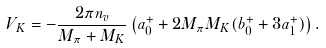<formula> <loc_0><loc_0><loc_500><loc_500>V _ { K } = - \frac { 2 \pi n _ { v } } { M _ { \pi } + M _ { K } } \left ( a _ { 0 } ^ { + } + 2 M _ { \pi } M _ { K } ( b _ { 0 } ^ { + } + 3 a _ { 1 } ^ { + } ) \right ) .</formula> 